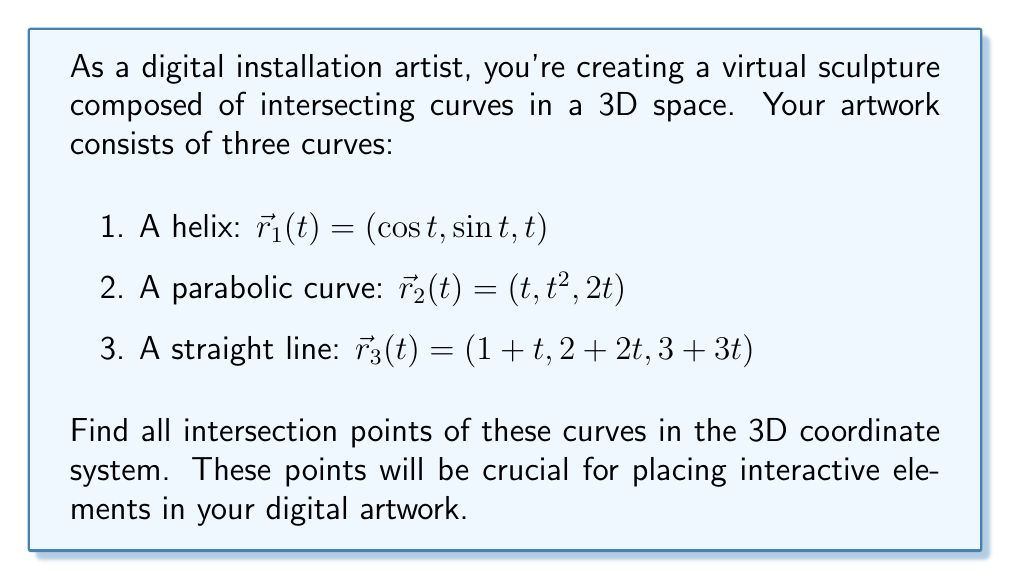What is the answer to this math problem? To find the intersection points, we need to solve the system of equations formed by equating the components of each curve:

1. For the helix and parabolic curve intersection:
   $$\cos t_1 = t_2$$
   $$\sin t_1 = t_2^2$$
   $$t_1 = 2t_2$$

2. For the helix and straight line intersection:
   $$\cos t_1 = 1 + t_3$$
   $$\sin t_1 = 2 + 2t_3$$
   $$t_1 = 3 + 3t_3$$

3. For the parabolic curve and straight line intersection:
   $$t_2 = 1 + t_3$$
   $$t_2^2 = 2 + 2t_3$$
   $$2t_2 = 3 + 3t_3$$

Let's solve each system:

1. Helix and parabolic curve:
   From $t_1 = 2t_2$, substitute into $\cos t_1 = t_2$:
   $$\cos (2t_2) = t_2$$
   This transcendental equation has multiple solutions, but we can find one numerically: $t_2 \approx 0.7390851332$
   Then, $t_1 \approx 1.4781702664$

   Verify: $\sin t_1 \approx 0.9962720762 \approx {(0.7390851332)}^2 = t_2^2$

   Point of intersection: $(0.7390851332, 0.5462677146, 1.4781702664)$

2. Helix and straight line:
   From $t_1 = 3 + 3t_3$, substitute into $\cos t_1 = 1 + t_3$:
   $$\cos (3 + 3t_3) = 1 + t_3$$
   This also has multiple solutions, but we can find one numerically: $t_3 \approx -0.3166701075$
   Then, $t_1 \approx 2.0499897775$

   Verify: $\sin t_1 \approx 0.8666600850 \approx 2 + 2(-0.3166701075) = 2 + 2t_3$

   Point of intersection: $(0.6833298925, 1.3666597700, 2.0499897775)$

3. Parabolic curve and straight line:
   From $t_2 = 1 + t_3$, substitute into $t_2^2 = 2 + 2t_3$:
   $${(1 + t_3)}^2 = 2 + 2t_3$$
   $$1 + 2t_3 + t_3^2 = 2 + 2t_3$$
   $$t_3^2 = 1$$
   $$t_3 = \pm 1$$

   When $t_3 = 1$, $t_2 = 2$
   Point of intersection: $(2, 4, 4)$

   When $t_3 = -1$, $t_2 = 0$
   Point of intersection: $(0, 0, 0)$
Answer: The curves intersect at four points:
1. $(0.7390851332, 0.5462677146, 1.4781702664)$
2. $(0.6833298925, 1.3666597700, 2.0499897775)$
3. $(2, 4, 4)$
4. $(0, 0, 0)$ 